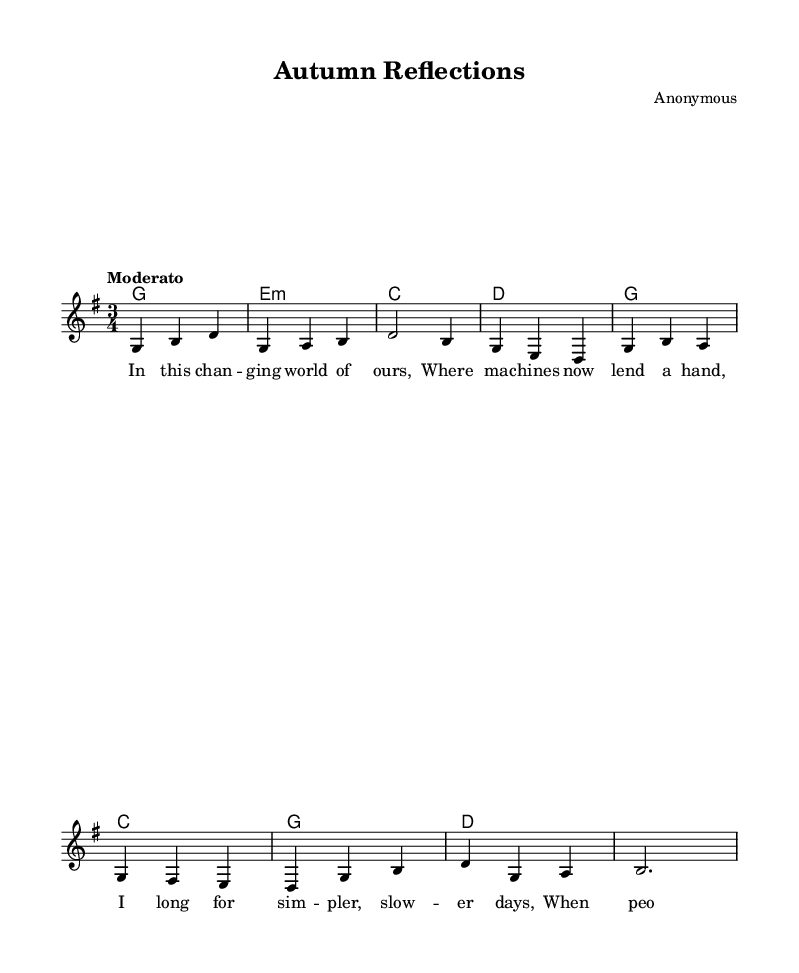What is the key signature of this music? The key signature is indicated at the start of the piece, showing one sharp (F#), which identifies the key as G major.
Answer: G major What is the time signature of this music? The time signature is located at the beginning of the score and is written as 3/4, indicating three beats per measure and a quarter note gets one beat.
Answer: 3/4 What is the tempo indication of this music? The tempo marking is located at the beginning of the score and is marked as "Moderato," which suggests a moderate pace, typically around 108-120 beats per minute.
Answer: Moderato How many measures are there in the melody? By counting the measures indicated in the melody line (each set of vertical lines represents a measure), there are 8 measures total in the melody.
Answer: 8 What style of music does this piece represent? The lyrics and the overall structure reveal themes of simplicity and reflection, typical of 1960s folk music, which often addressed societal changes and human connections.
Answer: Folk music Who is the composer of this piece? The composer is mentioned in the header of the score, indicating the piece was created by an anonymous composer.
Answer: Anonymous What lyrical theme is presented in this song? The lyrics convey a longing for simpler times in a changing world and relate to the societal shifts experienced during the 1960s, highlighting human experiences and connections.
Answer: Simpler, slower days 